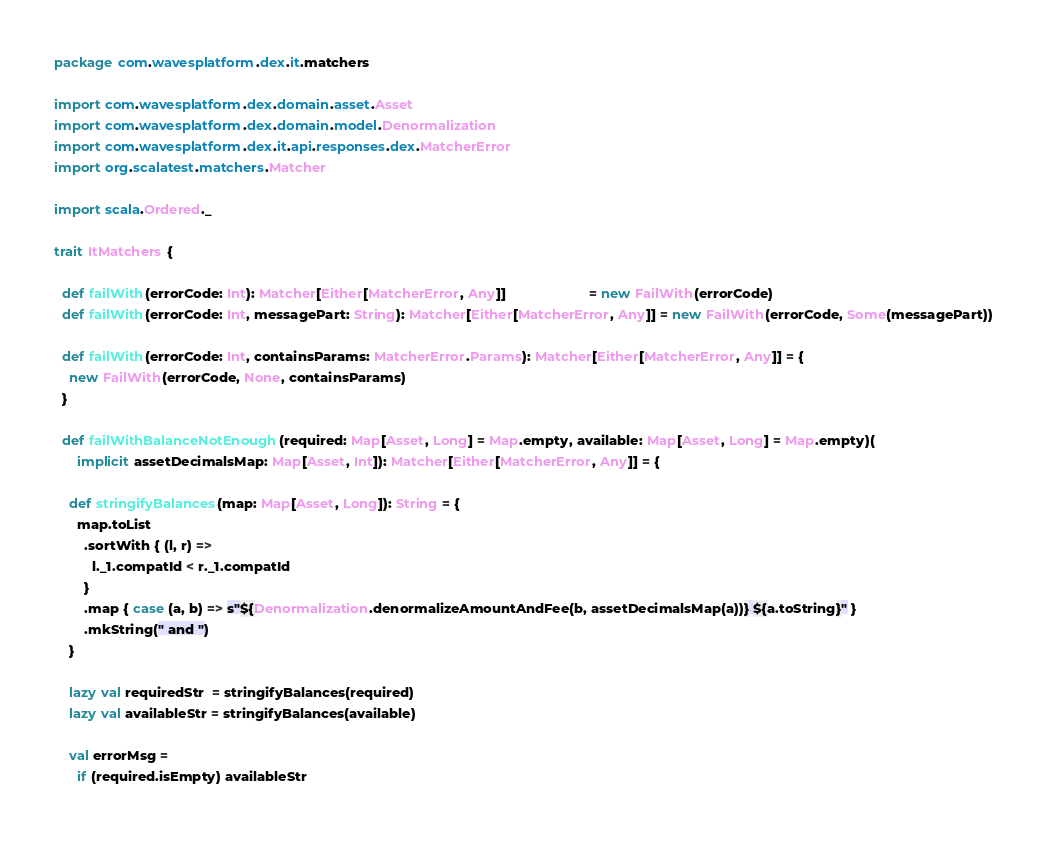Convert code to text. <code><loc_0><loc_0><loc_500><loc_500><_Scala_>package com.wavesplatform.dex.it.matchers

import com.wavesplatform.dex.domain.asset.Asset
import com.wavesplatform.dex.domain.model.Denormalization
import com.wavesplatform.dex.it.api.responses.dex.MatcherError
import org.scalatest.matchers.Matcher

import scala.Ordered._

trait ItMatchers {

  def failWith(errorCode: Int): Matcher[Either[MatcherError, Any]]                      = new FailWith(errorCode)
  def failWith(errorCode: Int, messagePart: String): Matcher[Either[MatcherError, Any]] = new FailWith(errorCode, Some(messagePart))

  def failWith(errorCode: Int, containsParams: MatcherError.Params): Matcher[Either[MatcherError, Any]] = {
    new FailWith(errorCode, None, containsParams)
  }

  def failWithBalanceNotEnough(required: Map[Asset, Long] = Map.empty, available: Map[Asset, Long] = Map.empty)(
      implicit assetDecimalsMap: Map[Asset, Int]): Matcher[Either[MatcherError, Any]] = {

    def stringifyBalances(map: Map[Asset, Long]): String = {
      map.toList
        .sortWith { (l, r) =>
          l._1.compatId < r._1.compatId
        }
        .map { case (a, b) => s"${Denormalization.denormalizeAmountAndFee(b, assetDecimalsMap(a))} ${a.toString}" }
        .mkString(" and ")
    }

    lazy val requiredStr  = stringifyBalances(required)
    lazy val availableStr = stringifyBalances(available)

    val errorMsg =
      if (required.isEmpty) availableStr</code> 